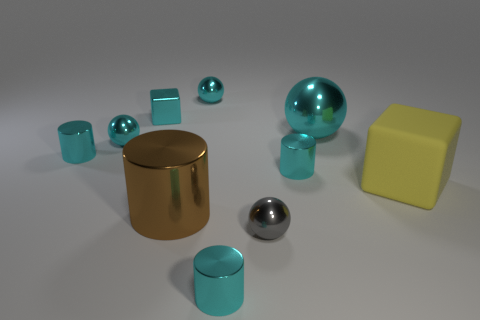Are there any other things that have the same material as the large cube?
Your response must be concise. No. Does the big sphere have the same color as the tiny block?
Make the answer very short. Yes. There is a large brown object; is its shape the same as the small cyan thing that is in front of the brown shiny cylinder?
Offer a very short reply. Yes. Is there a small green object?
Make the answer very short. No. How many small things are yellow matte spheres or gray shiny objects?
Provide a short and direct response. 1. Is the number of metal objects in front of the big ball greater than the number of tiny gray metallic spheres in front of the gray metal object?
Your answer should be very brief. Yes. Do the gray sphere and the tiny cylinder right of the small gray shiny thing have the same material?
Your response must be concise. Yes. The big shiny sphere is what color?
Offer a terse response. Cyan. What is the shape of the big metal thing in front of the big yellow cube?
Make the answer very short. Cylinder. How many red things are either big metal objects or blocks?
Give a very brief answer. 0. 